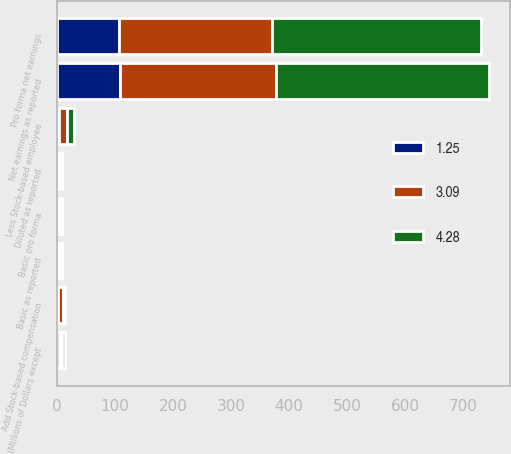Convert chart to OTSL. <chart><loc_0><loc_0><loc_500><loc_500><stacked_bar_chart><ecel><fcel>(Millions of Dollars except<fcel>Net earnings as reported<fcel>Add Stock-based compensation<fcel>Less Stock-based employee<fcel>Pro forma net earnings<fcel>Basic as reported<fcel>Basic pro forma<fcel>Diluted as reported<nl><fcel>3.09<fcel>4.39<fcel>269.6<fcel>8.3<fcel>13.9<fcel>264<fcel>3.23<fcel>3.17<fcel>3.16<nl><fcel>4.28<fcel>4.39<fcel>366.9<fcel>4.1<fcel>10.8<fcel>360.2<fcel>4.47<fcel>4.39<fcel>4.36<nl><fcel>1.25<fcel>4.39<fcel>107.9<fcel>1.7<fcel>3.6<fcel>106<fcel>1.28<fcel>1.26<fcel>1.27<nl></chart> 